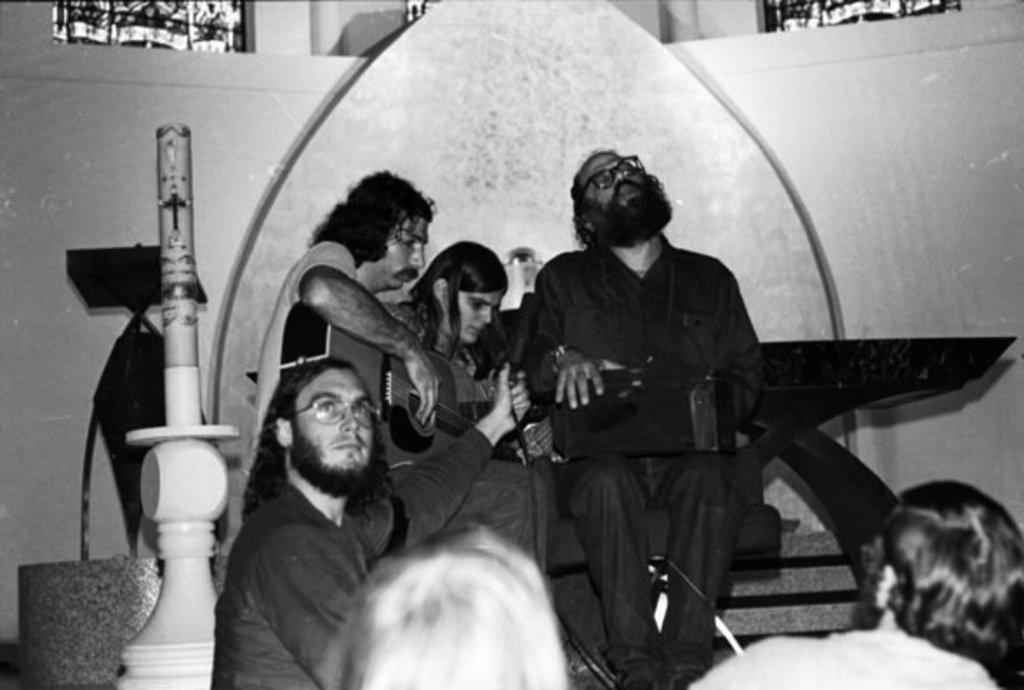How would you summarize this image in a sentence or two? In this image we can see some persons sitting at the background of the image playing some musical instruments and there is wall and windows and at the foreground of the image there are two persons sitting. 